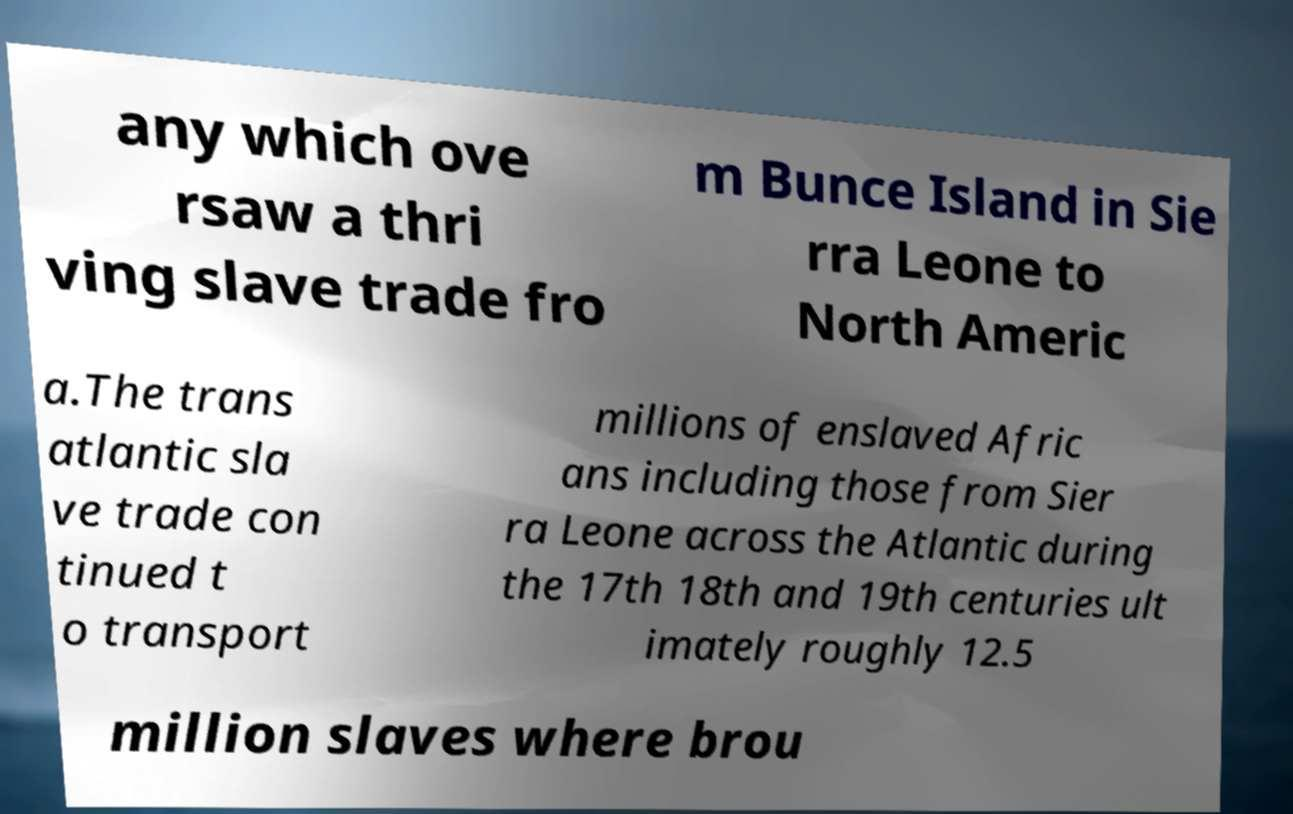There's text embedded in this image that I need extracted. Can you transcribe it verbatim? any which ove rsaw a thri ving slave trade fro m Bunce Island in Sie rra Leone to North Americ a.The trans atlantic sla ve trade con tinued t o transport millions of enslaved Afric ans including those from Sier ra Leone across the Atlantic during the 17th 18th and 19th centuries ult imately roughly 12.5 million slaves where brou 